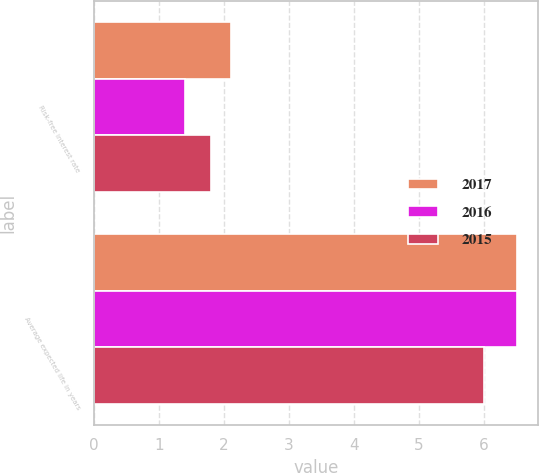Convert chart. <chart><loc_0><loc_0><loc_500><loc_500><stacked_bar_chart><ecel><fcel>Risk-free interest rate<fcel>Average expected life in years<nl><fcel>2017<fcel>2.1<fcel>6.5<nl><fcel>2016<fcel>1.4<fcel>6.5<nl><fcel>2015<fcel>1.8<fcel>6<nl></chart> 